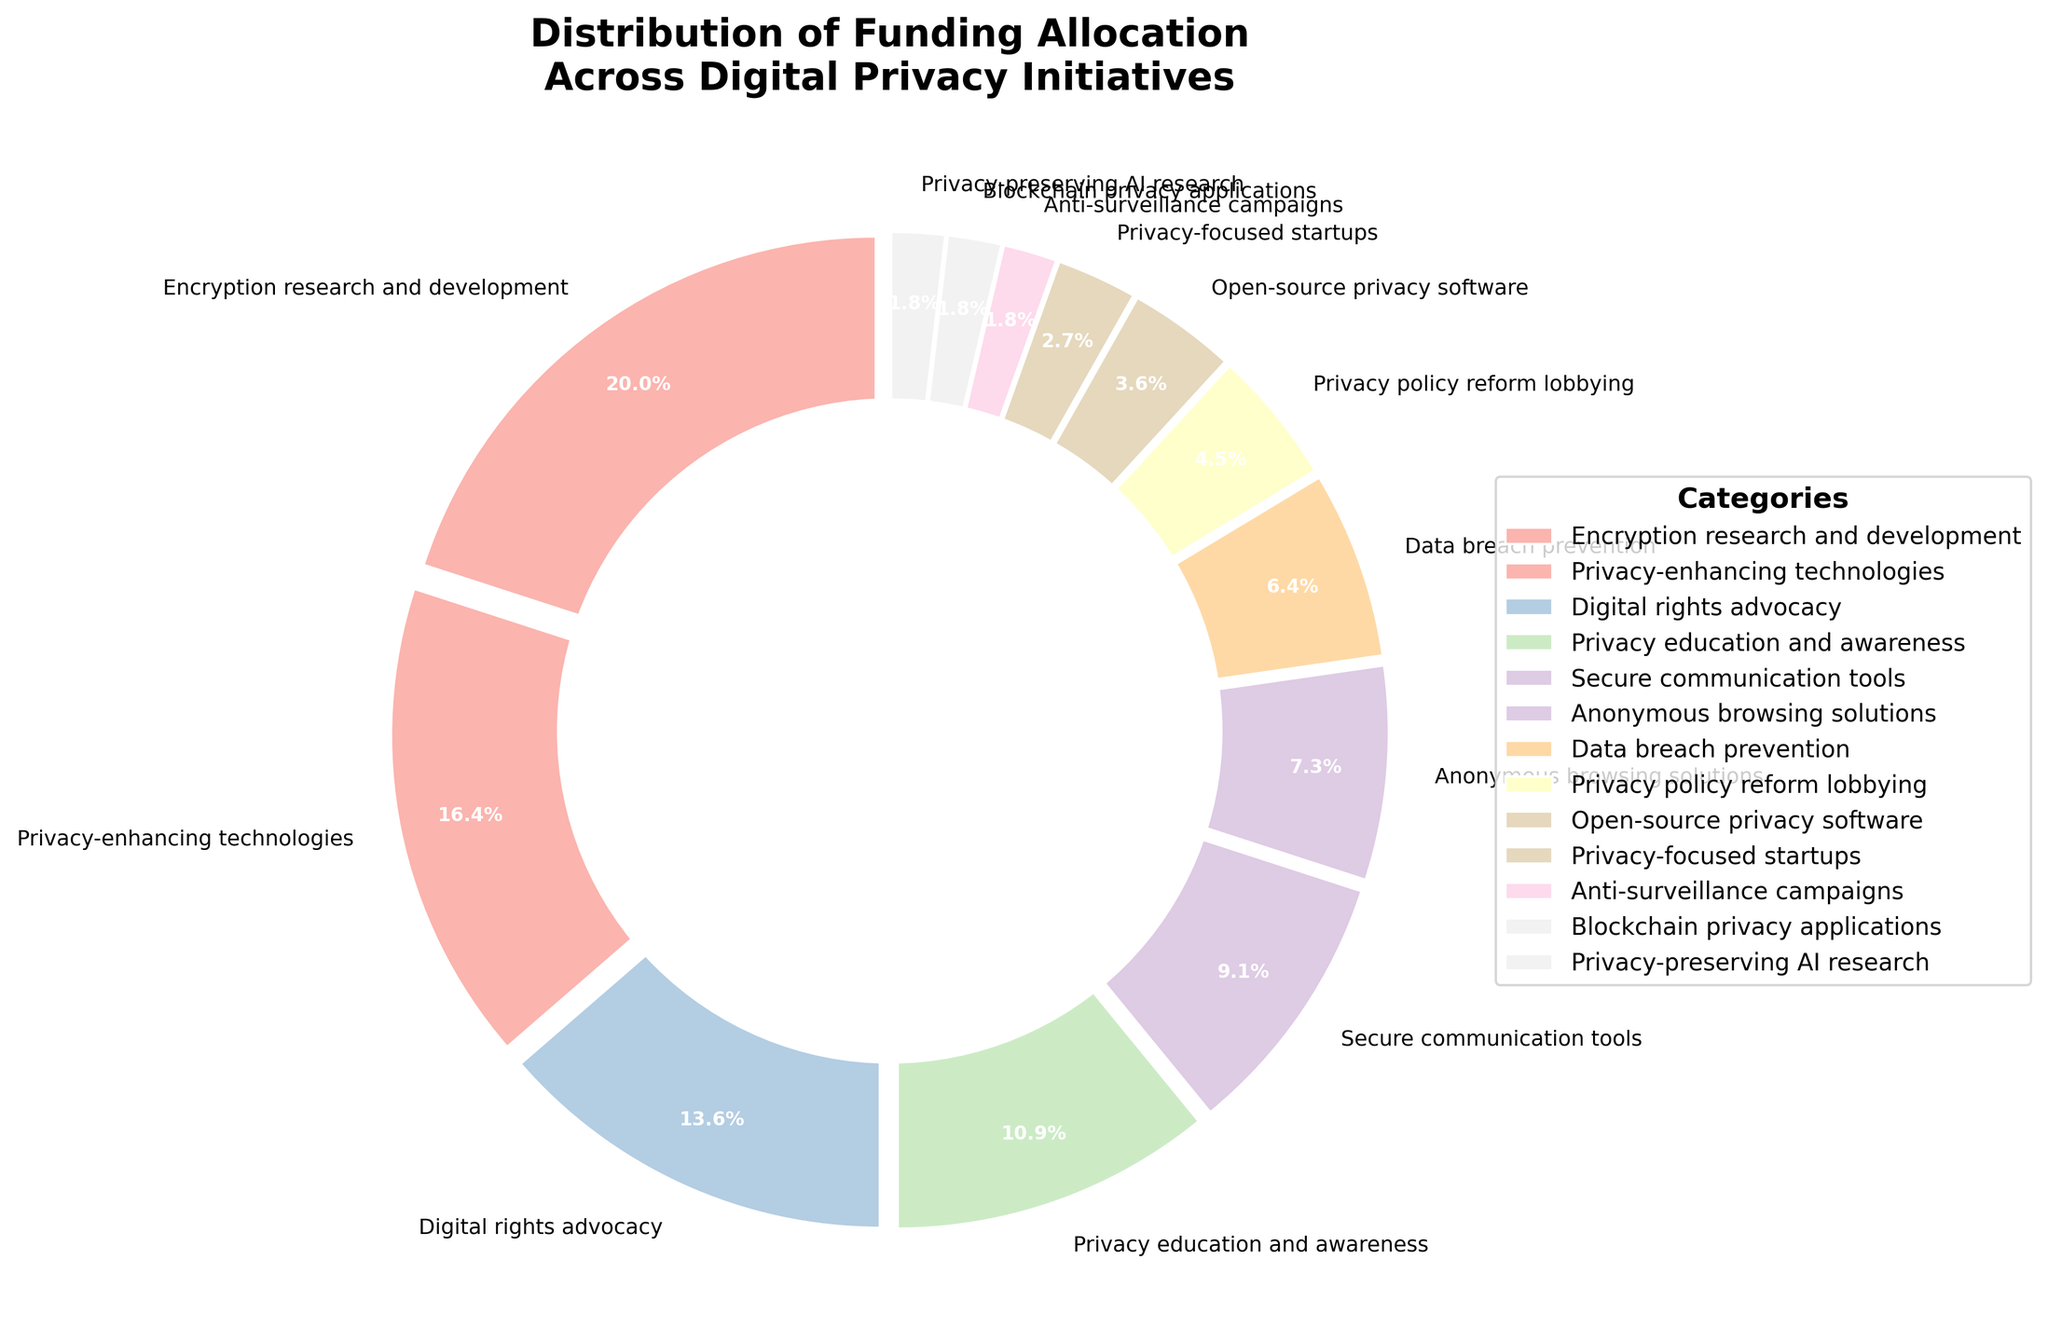Which category has the largest percentage allocation? The segment labeled "Encryption research and development" is visually the largest, with a percentage of 22%.
Answer: Encryption research and development What is the combined percentage allocation for Privacy-enhancing technologies and Digital rights advocacy? The figure shows Privacy-enhancing technologies at 18% and Digital rights advocacy at 15%. Adding these together results in 18% + 15% = 33%.
Answer: 33% Compare the allocations for Secure communication tools and Anonymous browsing solutions. Which one is higher? Secure communication tools have a percentage of 10%, while Anonymous browsing solutions have a percentage of 8%. Since 10% is greater than 8%, Secure communication tools have a higher allocation.
Answer: Secure communication tools What percentage of the funding is allocated to Privacy policy reform lobbying, Open-source privacy software, and Privacy-focused startups combined? The allocations for these categories are 5%, 4%, and 3%, respectively. Adding these together results in 5% + 4% + 3% = 12%.
Answer: 12% How does the percentage for Privacy education and awareness compare to that for Data breach prevention? Privacy education and awareness is allocated 12%, while Data breach prevention is allocated 7%. Since 12% is greater than 7%, Privacy education and awareness has a higher allocation.
Answer: Privacy education and awareness Which categories, if combined, amount to approximately one-third of the total funding allocation? Privacy-enhancing technologies (18%) and Digital rights advocacy (15%) combined make up 33%, which is approximately one-third of the total funding.
Answer: Privacy-enhancing technologies and Digital rights advocacy What percentage of the funding is allocated to categories with an allocation of less than 5% each? The categories with allocations less than 5% are Privacy policy reform lobbying (5%), Open-source privacy software (4%), Privacy-focused startups (3%), Anti-surveillance campaigns (2%), Blockchain privacy applications (2%), and Privacy-preserving AI research (2%). Adding these together results in 5% + 4% + 3% + 2% + 2% + 2% = 18%.
Answer: 18% How many categories have a funding allocation greater than 10%? The categories with allocations greater than 10% are Encryption research and development (22%), Privacy-enhancing technologies (18%), Digital rights advocacy (15%), and Privacy education and awareness (12%). Hence, there are 4 such categories.
Answer: 4 What is the approximate visual difference in percentage between the highest and lowest allocated categories? The highest allocation is Encryption research and development at 22%, and the lowest allocations are Anti-surveillance campaigns, Blockchain privacy applications, and Privacy-preserving AI research, each at 2%. The visual difference is 22% - 2% = 20%.
Answer: 20% 